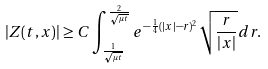<formula> <loc_0><loc_0><loc_500><loc_500>| Z ( t , x ) | \geq C \int _ { \frac { 1 } { \sqrt { \mu t } } } ^ { \frac { 2 } { \sqrt { \mu t } } } e ^ { - \frac { 1 } { 4 } ( | x | - r ) ^ { 2 } } \sqrt { \frac { r } { | x | } } d r .</formula> 